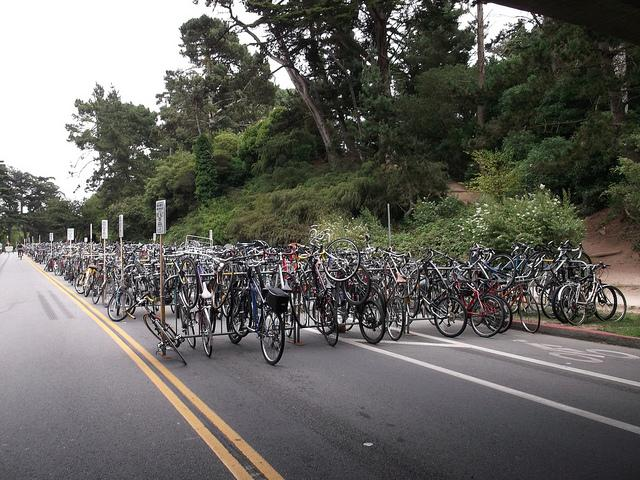What company is known for making the abundant items here? Please explain your reasoning. huffy. Huffy makes bikes. 